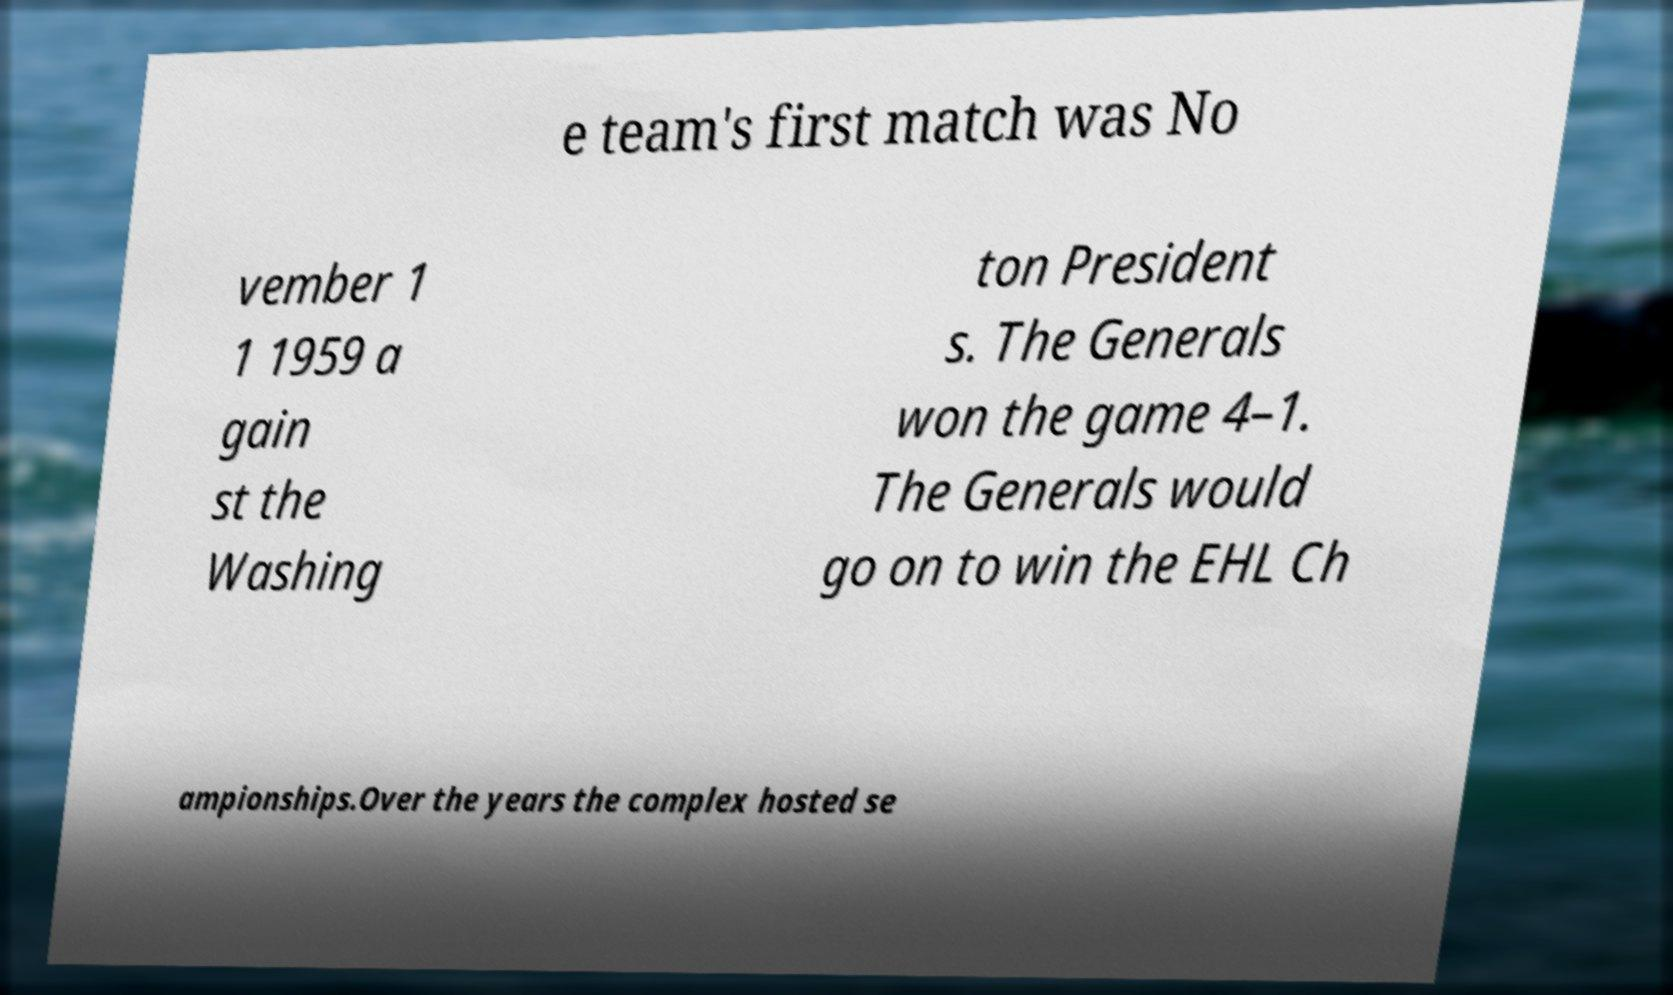Can you read and provide the text displayed in the image?This photo seems to have some interesting text. Can you extract and type it out for me? e team's first match was No vember 1 1 1959 a gain st the Washing ton President s. The Generals won the game 4–1. The Generals would go on to win the EHL Ch ampionships.Over the years the complex hosted se 